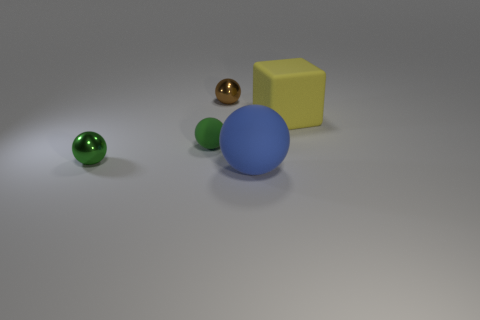Add 2 small green spheres. How many objects exist? 7 Subtract all small matte spheres. How many spheres are left? 3 Subtract all blue balls. How many balls are left? 3 Subtract 1 yellow cubes. How many objects are left? 4 Subtract all spheres. How many objects are left? 1 Subtract all green spheres. Subtract all blue cylinders. How many spheres are left? 2 Subtract all yellow cubes. How many blue spheres are left? 1 Subtract all metallic things. Subtract all large blocks. How many objects are left? 2 Add 3 tiny metal spheres. How many tiny metal spheres are left? 5 Add 1 large things. How many large things exist? 3 